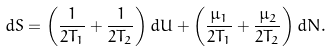Convert formula to latex. <formula><loc_0><loc_0><loc_500><loc_500>d S = \left ( \frac { 1 } { 2 T _ { 1 } } + \frac { 1 } { 2 T _ { 2 } } \right ) d U + \left ( \frac { \mu _ { 1 } } { 2 T _ { 1 } } + \frac { \mu _ { 2 } } { 2 T _ { 2 } } \right ) d N .</formula> 